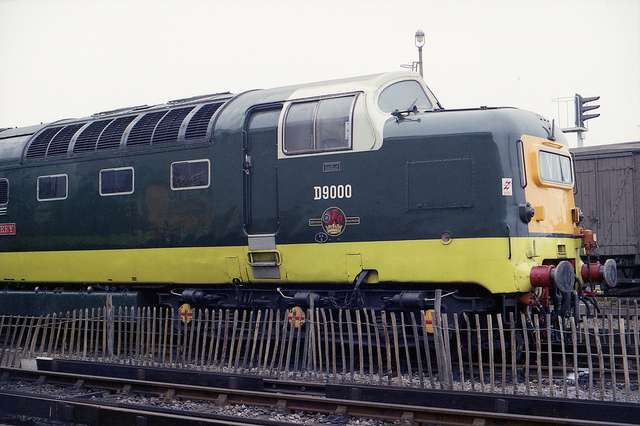Extract all visible text content from this image. D90000 BBY 